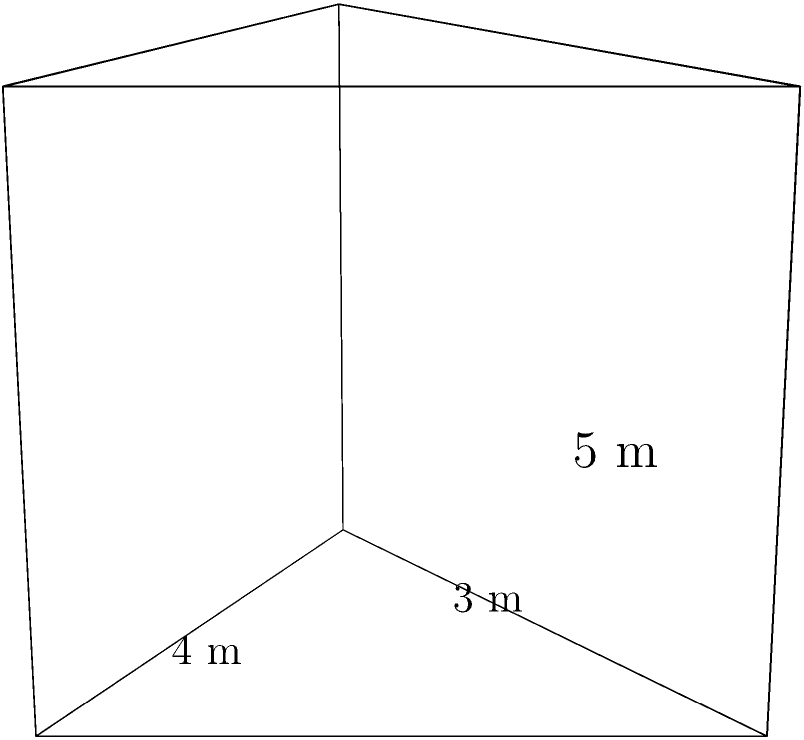In a Catholic church, a triangular prism-shaped reliquary is being designed to house sacred artifacts. The base of the reliquary is an isosceles triangle with a base of 4 meters and a height of 3 meters. If the length of the reliquary is 5 meters, what is its volume in cubic meters? To find the volume of the triangular prism, we need to follow these steps:

1. Calculate the area of the triangular base:
   The area of a triangle is given by the formula: $A = \frac{1}{2} \times base \times height$
   $A = \frac{1}{2} \times 4 \text{ m} \times 3 \text{ m} = 6 \text{ m}^2$

2. Apply the volume formula for a prism:
   The volume of a prism is given by the formula: $V = A \times l$, where $A$ is the area of the base and $l$ is the length of the prism.
   
   $V = 6 \text{ m}^2 \times 5 \text{ m} = 30 \text{ m}^3$

This calculation gives us the volume of the reliquary, which symbolically represents the magnitude of God's grace contained within the sacred artifacts.
Answer: $30 \text{ m}^3$ 